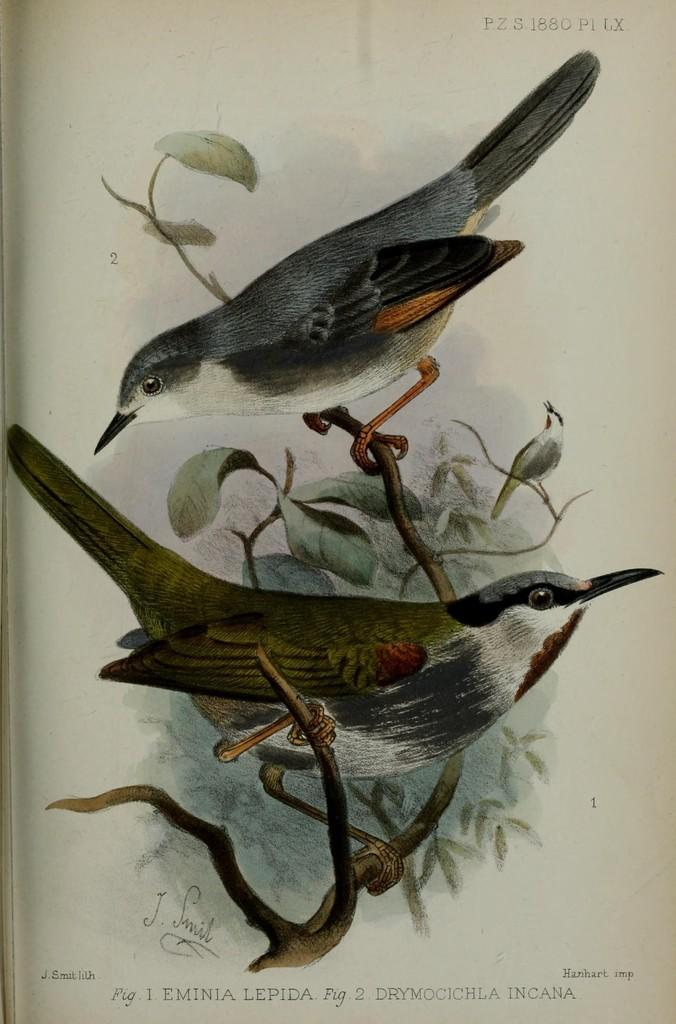What is the main subject of the painting in the image? The painting depicts two birds. Where are the birds located in the painting? The birds are sitting on a stem in the painting. What else can be seen in the painting besides the birds? There are leaves associated with the stem in the painting. What type of yarn is being used to create the slope in the painting? There is no slope or yarn present in the painting; it features two birds sitting on a stem with leaves. 